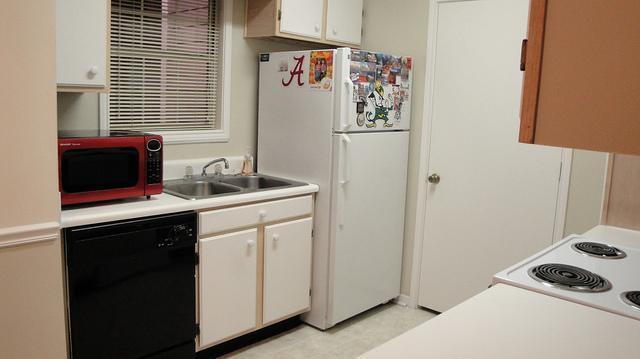How many ovens are there?
Give a very brief answer. 2. 